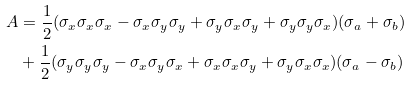<formula> <loc_0><loc_0><loc_500><loc_500>A & = \frac { 1 } { 2 } ( \sigma _ { x } \sigma _ { x } \sigma _ { x } - \sigma _ { x } \sigma _ { y } \sigma _ { y } + \sigma _ { y } \sigma _ { x } \sigma _ { y } + \sigma _ { y } \sigma _ { y } \sigma _ { x } ) ( \sigma _ { a } + \sigma _ { b } ) \\ & + \frac { 1 } { 2 } ( \sigma _ { y } \sigma _ { y } \sigma _ { y } - \sigma _ { x } \sigma _ { y } \sigma _ { x } + \sigma _ { x } \sigma _ { x } \sigma _ { y } + \sigma _ { y } \sigma _ { x } \sigma _ { x } ) ( \sigma _ { a } - \sigma _ { b } )</formula> 